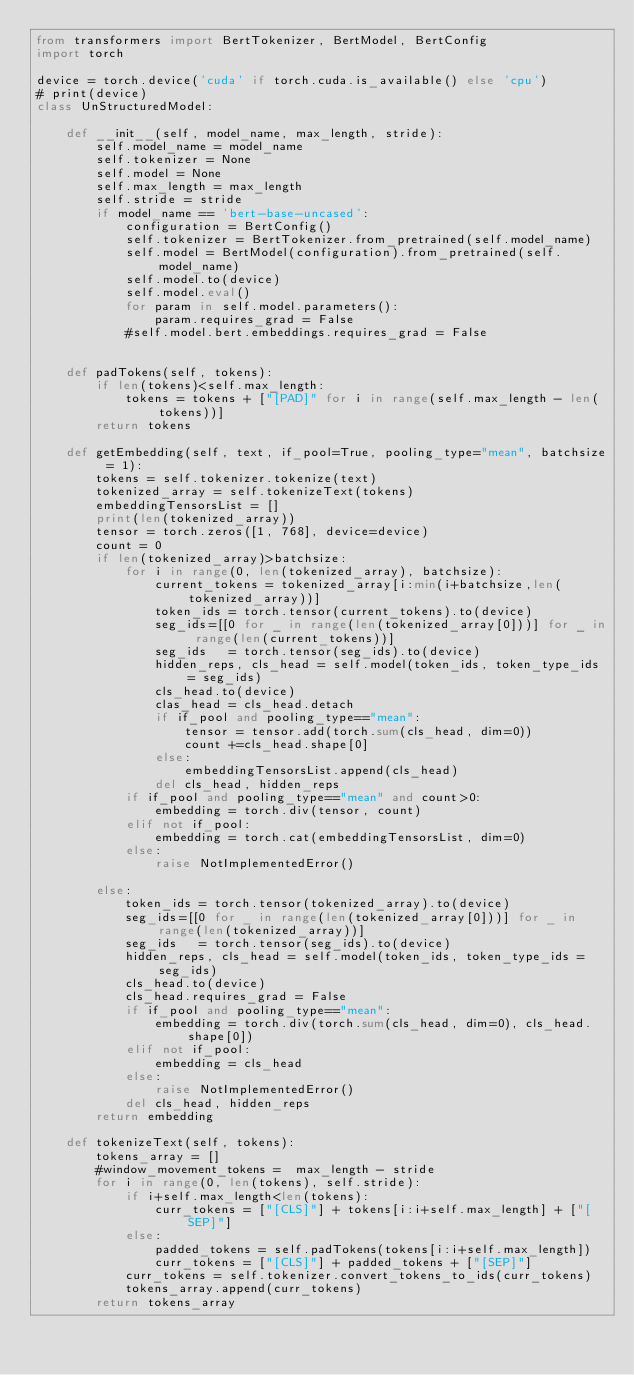<code> <loc_0><loc_0><loc_500><loc_500><_Python_>from transformers import BertTokenizer, BertModel, BertConfig
import torch

device = torch.device('cuda' if torch.cuda.is_available() else 'cpu')
# print(device)
class UnStructuredModel:

    def __init__(self, model_name, max_length, stride):
        self.model_name = model_name
        self.tokenizer = None
        self.model = None
        self.max_length = max_length
        self.stride = stride
        if model_name == 'bert-base-uncased':
            configuration = BertConfig()
            self.tokenizer = BertTokenizer.from_pretrained(self.model_name)
            self.model = BertModel(configuration).from_pretrained(self.model_name)
            self.model.to(device)
            self.model.eval()
            for param in self.model.parameters():
                param.requires_grad = False
            #self.model.bert.embeddings.requires_grad = False


    def padTokens(self, tokens):
        if len(tokens)<self.max_length:
            tokens = tokens + ["[PAD]" for i in range(self.max_length - len(tokens))]
        return tokens

    def getEmbedding(self, text, if_pool=True, pooling_type="mean", batchsize = 1):
        tokens = self.tokenizer.tokenize(text)
        tokenized_array = self.tokenizeText(tokens)
        embeddingTensorsList = []
        print(len(tokenized_array))
        tensor = torch.zeros([1, 768], device=device)
        count = 0
        if len(tokenized_array)>batchsize:
            for i in range(0, len(tokenized_array), batchsize):
                current_tokens = tokenized_array[i:min(i+batchsize,len(tokenized_array))]
                token_ids = torch.tensor(current_tokens).to(device)
                seg_ids=[[0 for _ in range(len(tokenized_array[0]))] for _ in range(len(current_tokens))]
                seg_ids   = torch.tensor(seg_ids).to(device)
                hidden_reps, cls_head = self.model(token_ids, token_type_ids = seg_ids)
                cls_head.to(device)
                clas_head = cls_head.detach
                if if_pool and pooling_type=="mean":
                    tensor = tensor.add(torch.sum(cls_head, dim=0))
                    count +=cls_head.shape[0]
                else:
                    embeddingTensorsList.append(cls_head)
                del cls_head, hidden_reps
            if if_pool and pooling_type=="mean" and count>0:
                embedding = torch.div(tensor, count)
            elif not if_pool:
                embedding = torch.cat(embeddingTensorsList, dim=0)
            else:
                raise NotImplementedError()

        else:
            token_ids = torch.tensor(tokenized_array).to(device)
            seg_ids=[[0 for _ in range(len(tokenized_array[0]))] for _ in range(len(tokenized_array))]
            seg_ids   = torch.tensor(seg_ids).to(device)
            hidden_reps, cls_head = self.model(token_ids, token_type_ids = seg_ids)
            cls_head.to(device)
            cls_head.requires_grad = False
            if if_pool and pooling_type=="mean":
                embedding = torch.div(torch.sum(cls_head, dim=0), cls_head.shape[0])
            elif not if_pool:
                embedding = cls_head
            else:
                raise NotImplementedError()
            del cls_head, hidden_reps
        return embedding

    def tokenizeText(self, tokens):
        tokens_array = []
        #window_movement_tokens =  max_length - stride
        for i in range(0, len(tokens), self.stride):
            if i+self.max_length<len(tokens):
                curr_tokens = ["[CLS]"] + tokens[i:i+self.max_length] + ["[SEP]"]
            else:
                padded_tokens = self.padTokens(tokens[i:i+self.max_length])
                curr_tokens = ["[CLS]"] + padded_tokens + ["[SEP]"]
            curr_tokens = self.tokenizer.convert_tokens_to_ids(curr_tokens)
            tokens_array.append(curr_tokens)
        return tokens_array
    </code> 